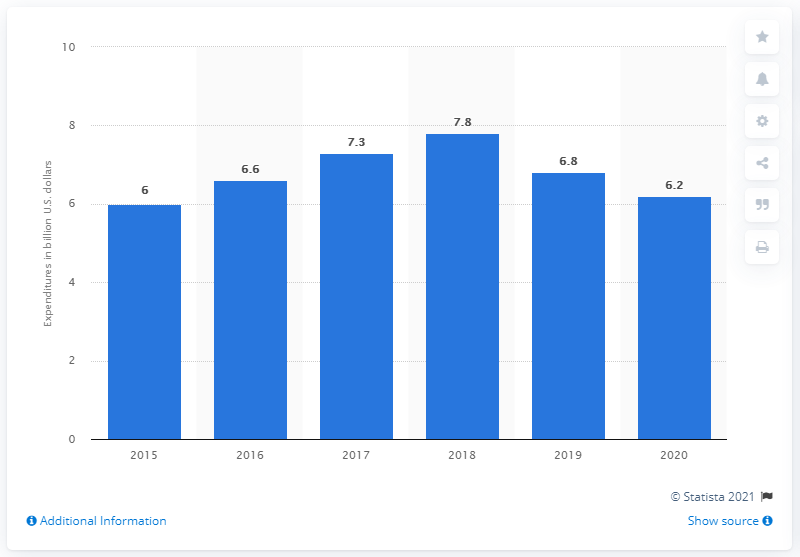Outline some significant characteristics in this image. General Motors' research and development intensity is 6.2%. General Motors invested approximately $6.2 billion in research and development expenditures in 2020. 